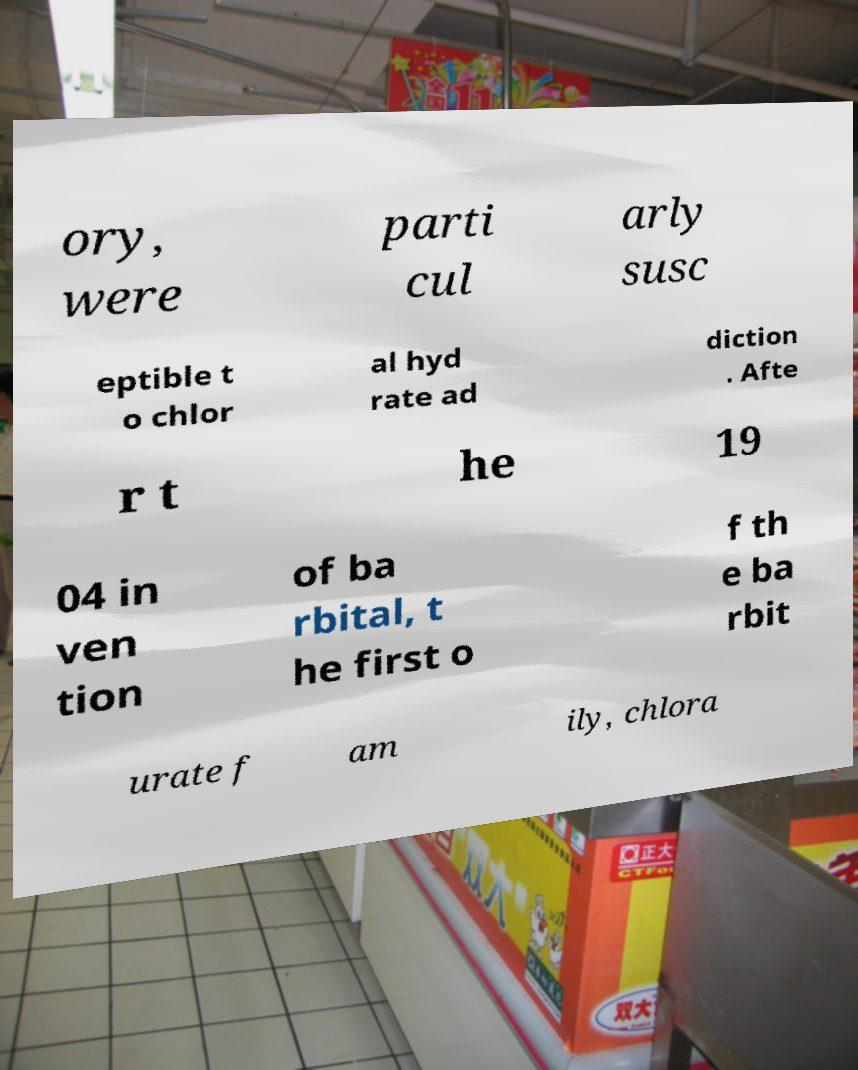I need the written content from this picture converted into text. Can you do that? ory, were parti cul arly susc eptible t o chlor al hyd rate ad diction . Afte r t he 19 04 in ven tion of ba rbital, t he first o f th e ba rbit urate f am ily, chlora 